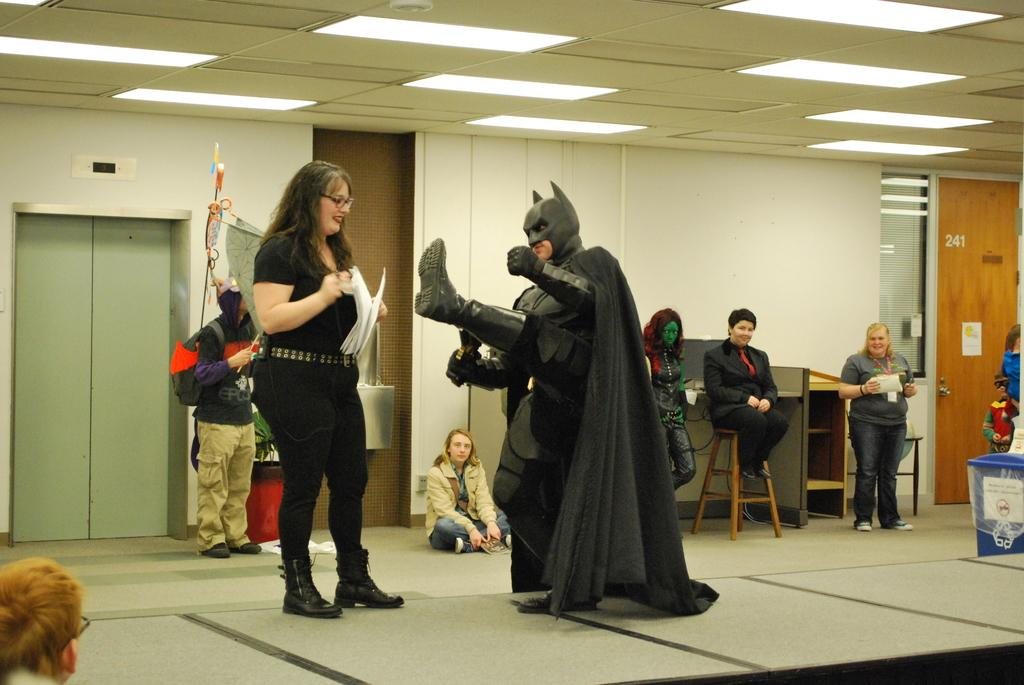What are the people in the image doing? There is a group of people on the floor in the image. What piece of furniture can be seen in the image? There is a stool in the image. What architectural feature is present in the image? There is a door and a wall in the image. What can be seen in the background of the image? There is a roof and lights visible in the background. What else is present in the image besides the people and furniture? There are objects in the image. What type of unit can be seen in the image? There is no unit present in the image. Is there a basin visible in the image? There is no basin present in the image. 